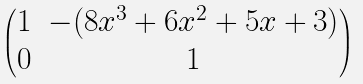<formula> <loc_0><loc_0><loc_500><loc_500>\begin{pmatrix} 1 & - ( 8 x ^ { 3 } + 6 x ^ { 2 } + 5 x + 3 ) \\ 0 & 1 \end{pmatrix}</formula> 